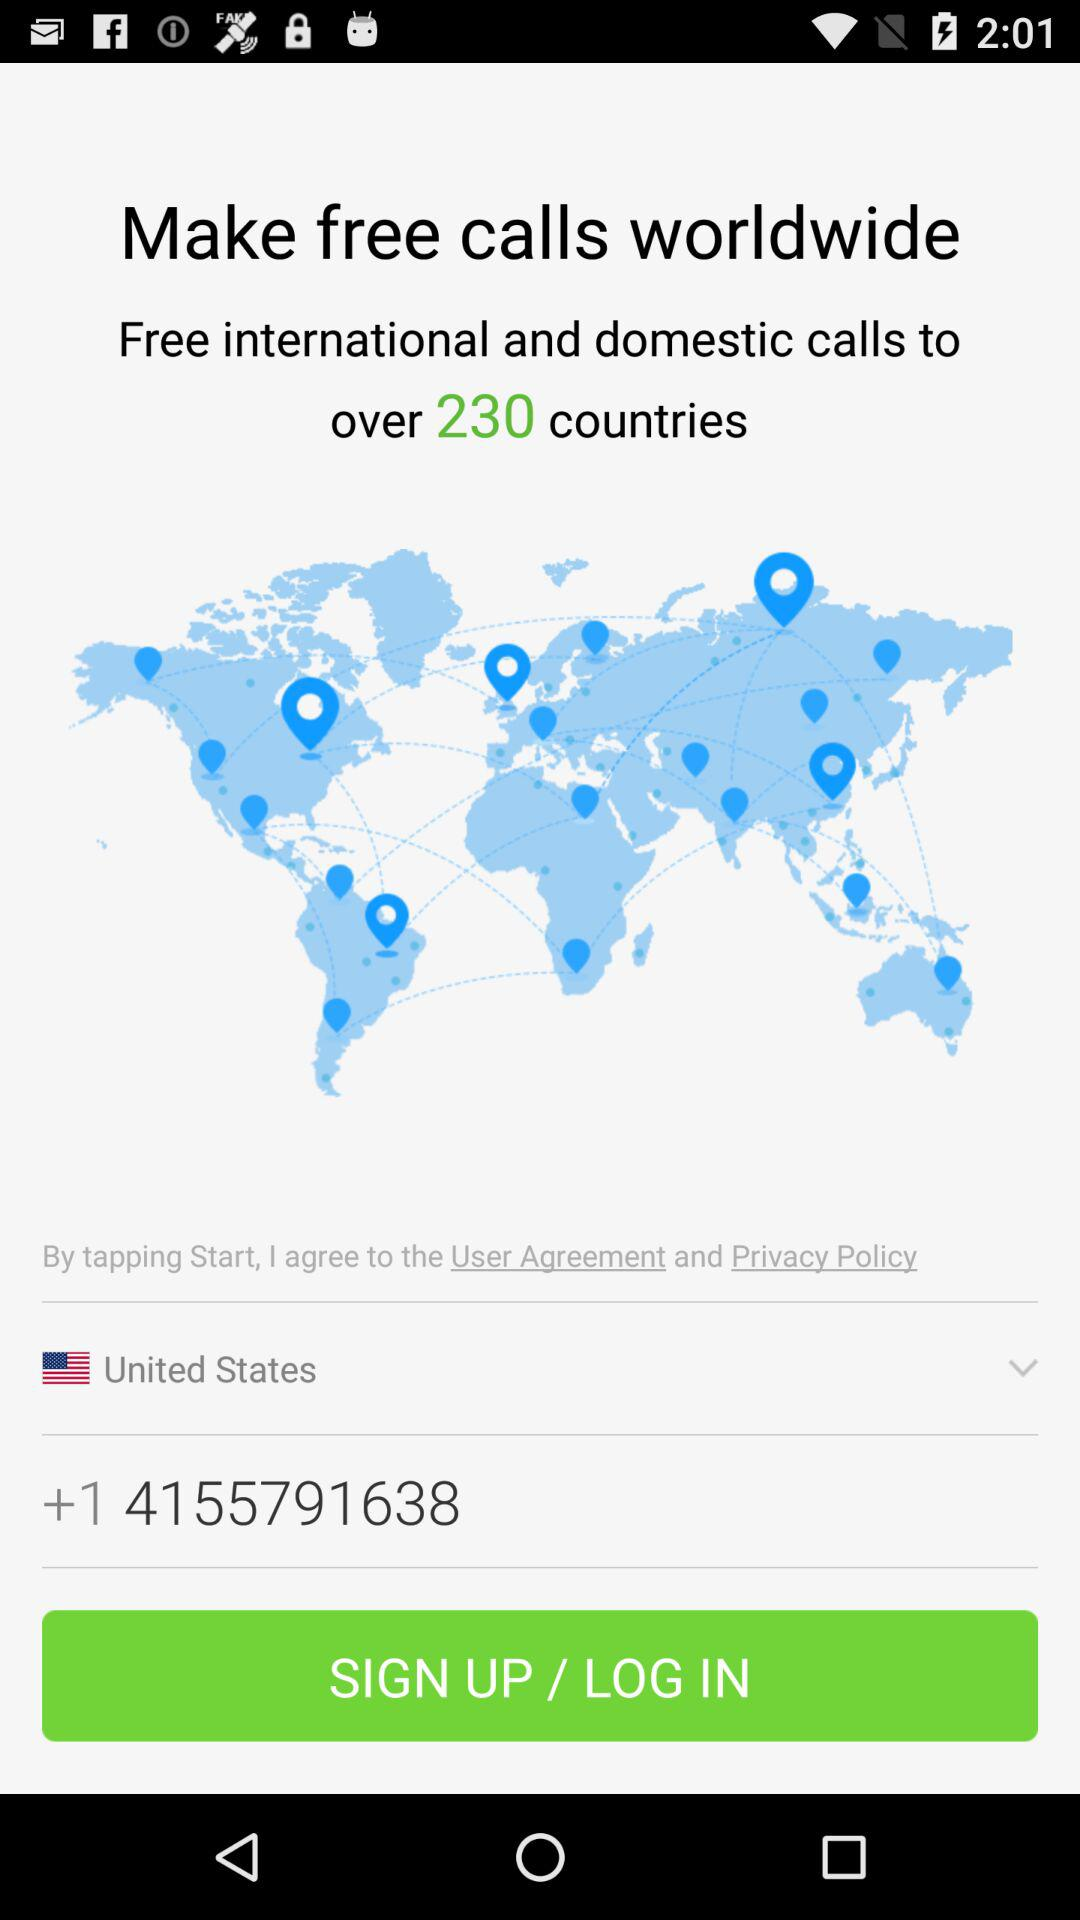What's the phone number? The phone number is +1 4155791638. 